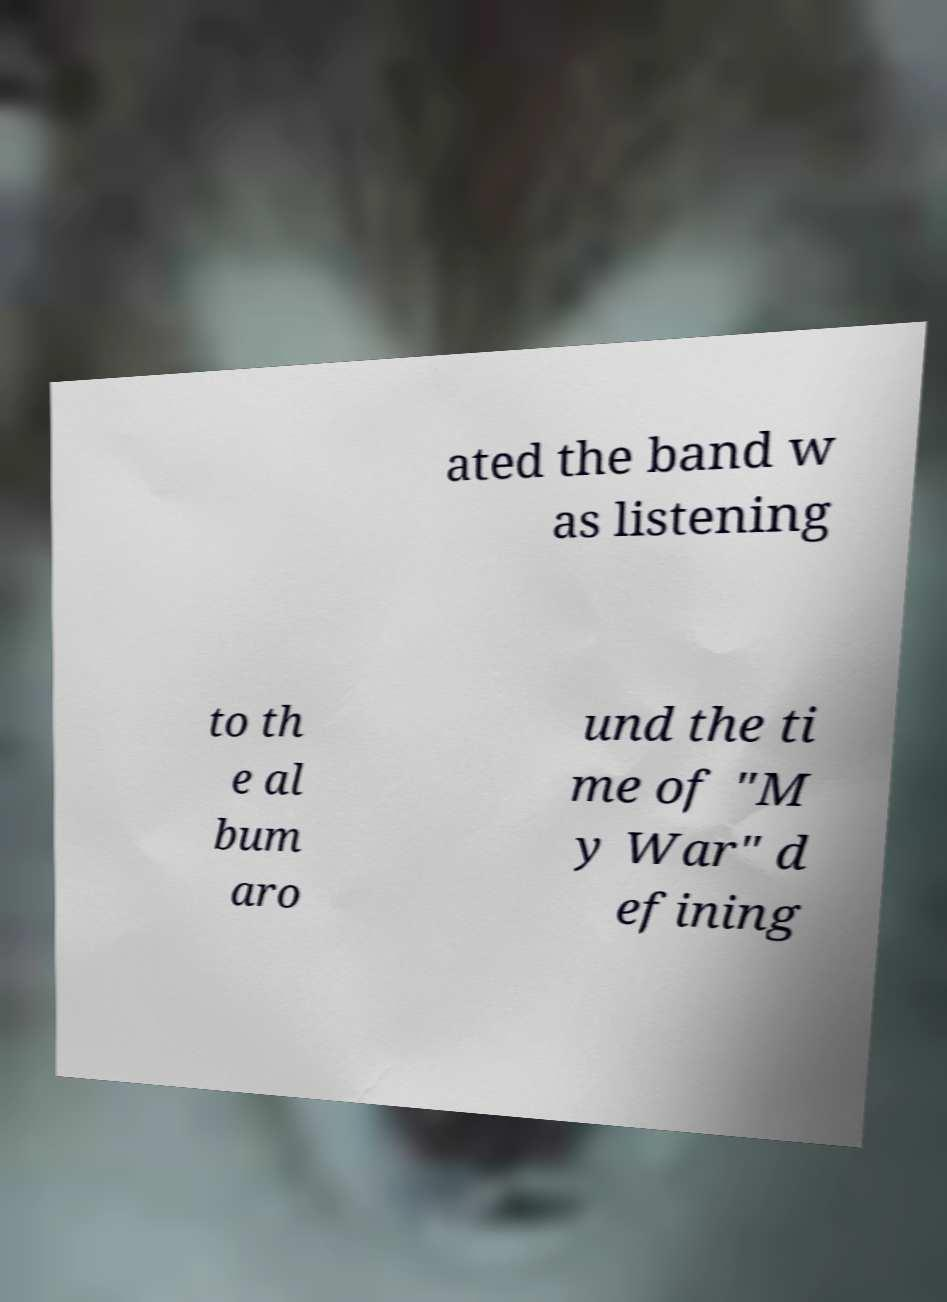I need the written content from this picture converted into text. Can you do that? ated the band w as listening to th e al bum aro und the ti me of "M y War" d efining 